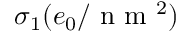Convert formula to latex. <formula><loc_0><loc_0><loc_500><loc_500>\sigma _ { 1 } ( e _ { 0 } / n m ^ { 2 } )</formula> 